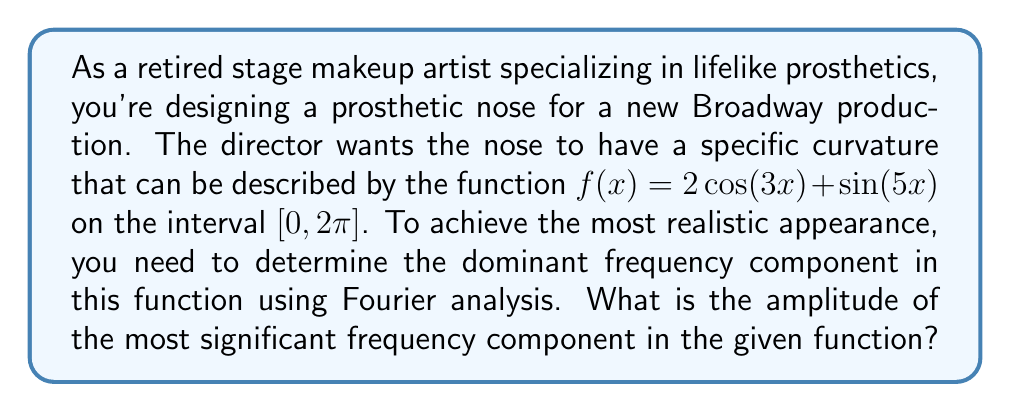Solve this math problem. To solve this problem, we'll use Fourier analysis to break down the given function into its frequency components. The steps are as follows:

1) The given function is already expressed as a sum of sinusoidal functions:

   $f(x) = 2\cos(3x) + \sin(5x)$

2) In Fourier analysis, we typically express functions in terms of cosine and sine functions with integer multiples of the fundamental frequency. Here, we already have this form.

3) The amplitudes of the frequency components are:
   - For $\cos(3x)$: $A_3 = 2$
   - For $\sin(5x)$: $B_5 = 1$

4) To compare the significance of these components, we need to consider their amplitudes. In Fourier analysis, the amplitude of a component is given by $\sqrt{A_n^2 + B_n^2}$ where $A_n$ is the coefficient of the cosine term and $B_n$ is the coefficient of the sine term for the nth harmonic.

5) For the $3x$ component: $\sqrt{2^2 + 0^2} = 2$
   For the $5x$ component: $\sqrt{0^2 + 1^2} = 1$

6) The larger amplitude indicates the more dominant frequency component.

Therefore, the most significant frequency component is the one with frequency 3, which has an amplitude of 2.
Answer: The amplitude of the most significant frequency component is 2. 